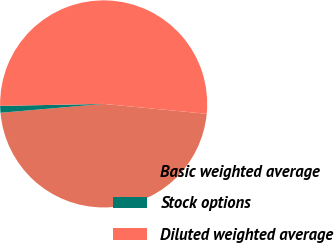<chart> <loc_0><loc_0><loc_500><loc_500><pie_chart><fcel>Basic weighted average<fcel>Stock options<fcel>Diluted weighted average<nl><fcel>47.12%<fcel>1.06%<fcel>51.83%<nl></chart> 